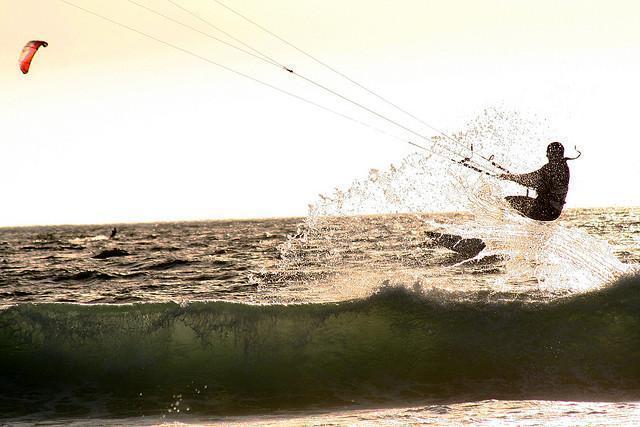The canopy wing is used for?
Answer the question by selecting the correct answer among the 4 following choices.
Options: Kiting, surfing, parasailing, swimming. Parasailing. 